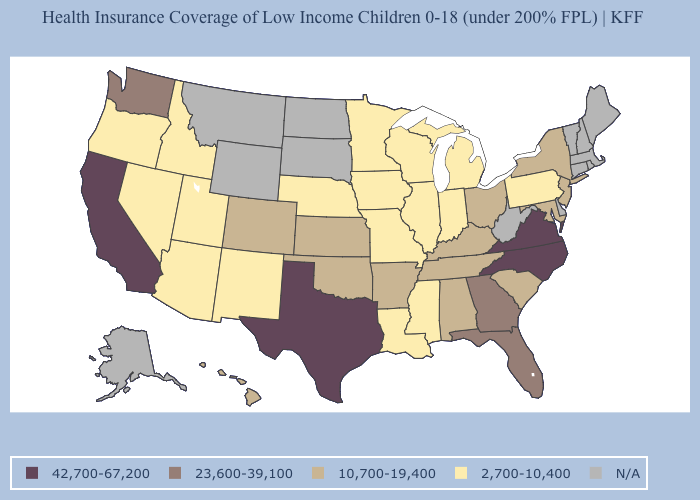Which states have the lowest value in the South?
Short answer required. Louisiana, Mississippi. Which states have the lowest value in the USA?
Be succinct. Arizona, Idaho, Illinois, Indiana, Iowa, Louisiana, Michigan, Minnesota, Mississippi, Missouri, Nebraska, Nevada, New Mexico, Oregon, Pennsylvania, Utah, Wisconsin. What is the value of New Hampshire?
Concise answer only. N/A. Which states have the highest value in the USA?
Answer briefly. California, North Carolina, Texas, Virginia. Does Texas have the highest value in the USA?
Answer briefly. Yes. Among the states that border Indiana , does Illinois have the highest value?
Concise answer only. No. Name the states that have a value in the range N/A?
Keep it brief. Alaska, Connecticut, Delaware, Maine, Massachusetts, Montana, New Hampshire, North Dakota, Rhode Island, South Dakota, Vermont, West Virginia, Wyoming. What is the value of Arizona?
Short answer required. 2,700-10,400. What is the value of North Carolina?
Give a very brief answer. 42,700-67,200. Does Minnesota have the highest value in the MidWest?
Quick response, please. No. What is the value of Pennsylvania?
Be succinct. 2,700-10,400. Name the states that have a value in the range 42,700-67,200?
Write a very short answer. California, North Carolina, Texas, Virginia. What is the value of Nevada?
Write a very short answer. 2,700-10,400. 